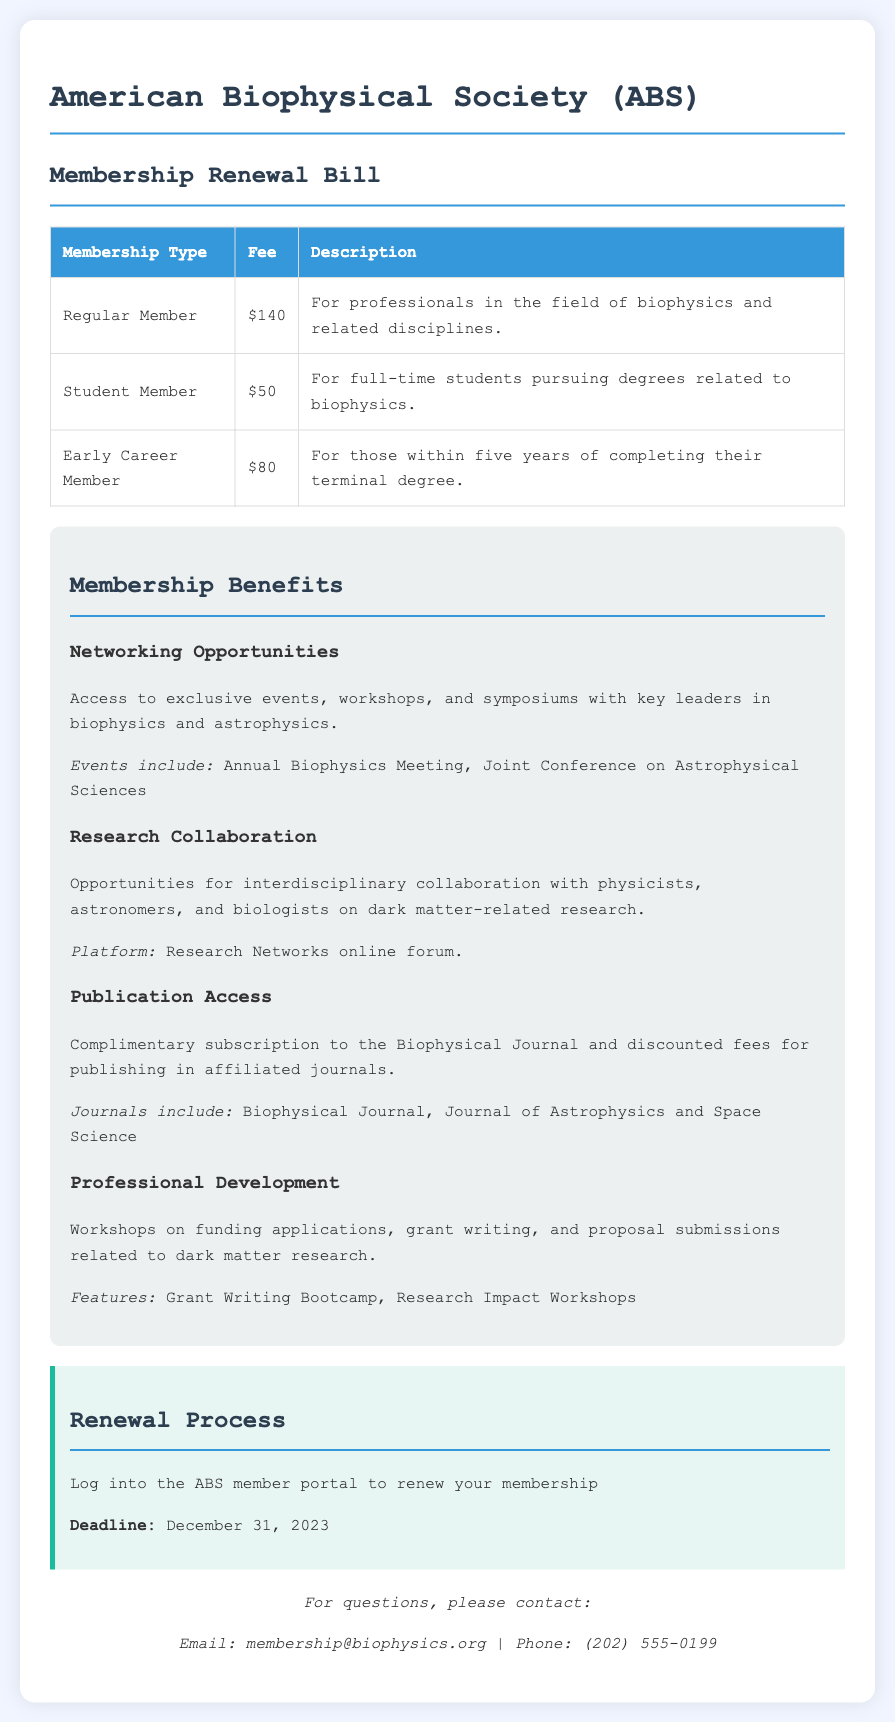What is the membership fee for a Regular Member? The fee for a Regular Member is specified in the fee table.
Answer: $140 What is the fee for Student Members? The fee for Student Members is listed in the fee table.
Answer: $50 When is the membership renewal deadline? The renewal deadline is mentioned in the renewal process section.
Answer: December 31, 2023 What opportunity is provided for interdisciplinary collaboration? The document mentions specific research collaboration opportunities related to biophysics and astrophysics.
Answer: Research Networks online forum What type of events can members access? The membership benefits section lists exclusive events that members can attend.
Answer: Annual Biophysics Meeting How much is the fee for Early Career Members? The fee for Early Career Members is included in the fee table.
Answer: $80 What benefit is offered regarding publishing? The benefits section outlines specific advantages related to publishing for members.
Answer: Discounted fees for publishing in affiliated journals Who can be contacted for questions about membership? The contact information section provides details for inquiries.
Answer: membership@biophysics.org What is one of the professional development topics mentioned? The document lists specific topics that are part of the professional development benefits.
Answer: Grant writing 